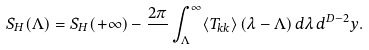Convert formula to latex. <formula><loc_0><loc_0><loc_500><loc_500>S _ { H } ( \Lambda ) = S _ { H } ( + \infty ) - \frac { 2 \pi } { } \int _ { \Lambda } ^ { \infty } \langle T _ { k k } \rangle \, ( \lambda - \Lambda ) \, d \lambda \, d ^ { D - 2 } y .</formula> 